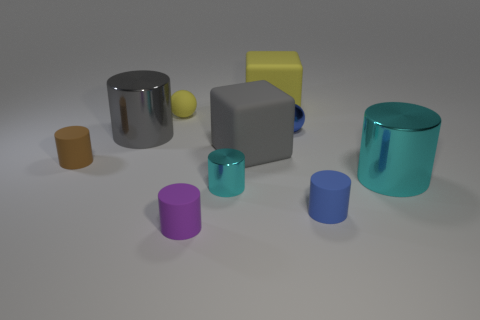There is a shiny cylinder behind the tiny brown cylinder; is there a cyan metal object that is behind it?
Your answer should be very brief. No. What size is the purple cylinder?
Offer a terse response. Small. How many objects are either large brown blocks or cyan things?
Offer a very short reply. 2. Does the large gray thing that is left of the large gray matte thing have the same material as the yellow thing that is behind the small rubber ball?
Provide a short and direct response. No. What is the color of the tiny sphere that is the same material as the tiny purple object?
Keep it short and to the point. Yellow. How many brown shiny balls are the same size as the purple cylinder?
Offer a terse response. 0. How many other things are there of the same color as the metallic sphere?
Provide a short and direct response. 1. Is there anything else that has the same size as the purple rubber object?
Your answer should be compact. Yes. There is a cyan shiny thing that is on the left side of the tiny blue matte object; is it the same shape as the blue object behind the brown rubber cylinder?
Your answer should be compact. No. There is a gray object that is the same size as the gray block; what shape is it?
Offer a terse response. Cylinder. 